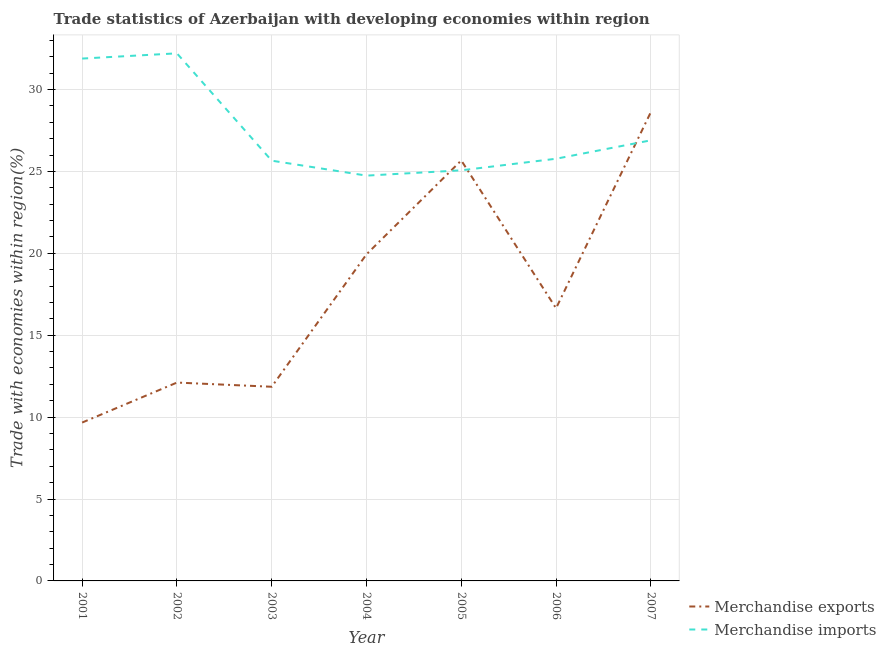Does the line corresponding to merchandise imports intersect with the line corresponding to merchandise exports?
Your answer should be compact. Yes. Is the number of lines equal to the number of legend labels?
Keep it short and to the point. Yes. What is the merchandise exports in 2004?
Keep it short and to the point. 19.94. Across all years, what is the maximum merchandise exports?
Offer a terse response. 28.62. Across all years, what is the minimum merchandise exports?
Offer a very short reply. 9.67. What is the total merchandise imports in the graph?
Provide a succinct answer. 192.24. What is the difference between the merchandise imports in 2001 and that in 2005?
Provide a succinct answer. 6.82. What is the difference between the merchandise exports in 2004 and the merchandise imports in 2005?
Ensure brevity in your answer.  -5.13. What is the average merchandise imports per year?
Offer a terse response. 27.46. In the year 2004, what is the difference between the merchandise exports and merchandise imports?
Provide a succinct answer. -4.8. What is the ratio of the merchandise exports in 2006 to that in 2007?
Ensure brevity in your answer.  0.58. Is the difference between the merchandise exports in 2001 and 2005 greater than the difference between the merchandise imports in 2001 and 2005?
Provide a short and direct response. No. What is the difference between the highest and the second highest merchandise imports?
Make the answer very short. 0.32. What is the difference between the highest and the lowest merchandise imports?
Offer a terse response. 7.47. In how many years, is the merchandise exports greater than the average merchandise exports taken over all years?
Your response must be concise. 3. Does the merchandise imports monotonically increase over the years?
Offer a terse response. No. Is the merchandise exports strictly less than the merchandise imports over the years?
Provide a short and direct response. No. How many lines are there?
Ensure brevity in your answer.  2. Does the graph contain grids?
Your response must be concise. Yes. Where does the legend appear in the graph?
Your answer should be compact. Bottom right. How many legend labels are there?
Your answer should be compact. 2. How are the legend labels stacked?
Your answer should be very brief. Vertical. What is the title of the graph?
Your answer should be compact. Trade statistics of Azerbaijan with developing economies within region. Does "Taxes on exports" appear as one of the legend labels in the graph?
Ensure brevity in your answer.  No. What is the label or title of the Y-axis?
Offer a terse response. Trade with economies within region(%). What is the Trade with economies within region(%) in Merchandise exports in 2001?
Give a very brief answer. 9.67. What is the Trade with economies within region(%) in Merchandise imports in 2001?
Offer a terse response. 31.89. What is the Trade with economies within region(%) of Merchandise exports in 2002?
Provide a succinct answer. 12.11. What is the Trade with economies within region(%) of Merchandise imports in 2002?
Your answer should be very brief. 32.21. What is the Trade with economies within region(%) in Merchandise exports in 2003?
Your answer should be compact. 11.85. What is the Trade with economies within region(%) of Merchandise imports in 2003?
Offer a very short reply. 25.66. What is the Trade with economies within region(%) in Merchandise exports in 2004?
Ensure brevity in your answer.  19.94. What is the Trade with economies within region(%) of Merchandise imports in 2004?
Provide a succinct answer. 24.74. What is the Trade with economies within region(%) in Merchandise exports in 2005?
Your answer should be compact. 25.67. What is the Trade with economies within region(%) of Merchandise imports in 2005?
Make the answer very short. 25.07. What is the Trade with economies within region(%) in Merchandise exports in 2006?
Offer a terse response. 16.65. What is the Trade with economies within region(%) of Merchandise imports in 2006?
Keep it short and to the point. 25.77. What is the Trade with economies within region(%) of Merchandise exports in 2007?
Your answer should be compact. 28.62. What is the Trade with economies within region(%) of Merchandise imports in 2007?
Make the answer very short. 26.9. Across all years, what is the maximum Trade with economies within region(%) in Merchandise exports?
Make the answer very short. 28.62. Across all years, what is the maximum Trade with economies within region(%) of Merchandise imports?
Your answer should be very brief. 32.21. Across all years, what is the minimum Trade with economies within region(%) of Merchandise exports?
Your response must be concise. 9.67. Across all years, what is the minimum Trade with economies within region(%) in Merchandise imports?
Give a very brief answer. 24.74. What is the total Trade with economies within region(%) of Merchandise exports in the graph?
Provide a succinct answer. 124.51. What is the total Trade with economies within region(%) of Merchandise imports in the graph?
Offer a very short reply. 192.24. What is the difference between the Trade with economies within region(%) of Merchandise exports in 2001 and that in 2002?
Your answer should be very brief. -2.44. What is the difference between the Trade with economies within region(%) of Merchandise imports in 2001 and that in 2002?
Your answer should be compact. -0.32. What is the difference between the Trade with economies within region(%) in Merchandise exports in 2001 and that in 2003?
Keep it short and to the point. -2.18. What is the difference between the Trade with economies within region(%) of Merchandise imports in 2001 and that in 2003?
Make the answer very short. 6.23. What is the difference between the Trade with economies within region(%) of Merchandise exports in 2001 and that in 2004?
Offer a terse response. -10.27. What is the difference between the Trade with economies within region(%) in Merchandise imports in 2001 and that in 2004?
Give a very brief answer. 7.15. What is the difference between the Trade with economies within region(%) of Merchandise exports in 2001 and that in 2005?
Give a very brief answer. -16. What is the difference between the Trade with economies within region(%) in Merchandise imports in 2001 and that in 2005?
Provide a short and direct response. 6.82. What is the difference between the Trade with economies within region(%) in Merchandise exports in 2001 and that in 2006?
Offer a terse response. -6.98. What is the difference between the Trade with economies within region(%) of Merchandise imports in 2001 and that in 2006?
Ensure brevity in your answer.  6.12. What is the difference between the Trade with economies within region(%) in Merchandise exports in 2001 and that in 2007?
Give a very brief answer. -18.95. What is the difference between the Trade with economies within region(%) of Merchandise imports in 2001 and that in 2007?
Your answer should be very brief. 4.99. What is the difference between the Trade with economies within region(%) in Merchandise exports in 2002 and that in 2003?
Provide a short and direct response. 0.26. What is the difference between the Trade with economies within region(%) in Merchandise imports in 2002 and that in 2003?
Provide a succinct answer. 6.55. What is the difference between the Trade with economies within region(%) of Merchandise exports in 2002 and that in 2004?
Provide a succinct answer. -7.83. What is the difference between the Trade with economies within region(%) of Merchandise imports in 2002 and that in 2004?
Your answer should be very brief. 7.47. What is the difference between the Trade with economies within region(%) in Merchandise exports in 2002 and that in 2005?
Provide a succinct answer. -13.56. What is the difference between the Trade with economies within region(%) in Merchandise imports in 2002 and that in 2005?
Keep it short and to the point. 7.14. What is the difference between the Trade with economies within region(%) of Merchandise exports in 2002 and that in 2006?
Keep it short and to the point. -4.54. What is the difference between the Trade with economies within region(%) in Merchandise imports in 2002 and that in 2006?
Your answer should be very brief. 6.43. What is the difference between the Trade with economies within region(%) in Merchandise exports in 2002 and that in 2007?
Ensure brevity in your answer.  -16.51. What is the difference between the Trade with economies within region(%) in Merchandise imports in 2002 and that in 2007?
Give a very brief answer. 5.31. What is the difference between the Trade with economies within region(%) in Merchandise exports in 2003 and that in 2004?
Provide a short and direct response. -8.09. What is the difference between the Trade with economies within region(%) of Merchandise imports in 2003 and that in 2004?
Ensure brevity in your answer.  0.91. What is the difference between the Trade with economies within region(%) in Merchandise exports in 2003 and that in 2005?
Your answer should be very brief. -13.82. What is the difference between the Trade with economies within region(%) in Merchandise imports in 2003 and that in 2005?
Your answer should be very brief. 0.59. What is the difference between the Trade with economies within region(%) in Merchandise exports in 2003 and that in 2006?
Offer a terse response. -4.79. What is the difference between the Trade with economies within region(%) in Merchandise imports in 2003 and that in 2006?
Your answer should be compact. -0.12. What is the difference between the Trade with economies within region(%) in Merchandise exports in 2003 and that in 2007?
Provide a succinct answer. -16.77. What is the difference between the Trade with economies within region(%) in Merchandise imports in 2003 and that in 2007?
Your answer should be very brief. -1.24. What is the difference between the Trade with economies within region(%) in Merchandise exports in 2004 and that in 2005?
Make the answer very short. -5.73. What is the difference between the Trade with economies within region(%) in Merchandise imports in 2004 and that in 2005?
Your answer should be very brief. -0.32. What is the difference between the Trade with economies within region(%) in Merchandise exports in 2004 and that in 2006?
Give a very brief answer. 3.29. What is the difference between the Trade with economies within region(%) of Merchandise imports in 2004 and that in 2006?
Provide a short and direct response. -1.03. What is the difference between the Trade with economies within region(%) in Merchandise exports in 2004 and that in 2007?
Ensure brevity in your answer.  -8.68. What is the difference between the Trade with economies within region(%) in Merchandise imports in 2004 and that in 2007?
Provide a succinct answer. -2.16. What is the difference between the Trade with economies within region(%) of Merchandise exports in 2005 and that in 2006?
Your response must be concise. 9.02. What is the difference between the Trade with economies within region(%) in Merchandise imports in 2005 and that in 2006?
Your response must be concise. -0.71. What is the difference between the Trade with economies within region(%) of Merchandise exports in 2005 and that in 2007?
Your response must be concise. -2.95. What is the difference between the Trade with economies within region(%) in Merchandise imports in 2005 and that in 2007?
Ensure brevity in your answer.  -1.83. What is the difference between the Trade with economies within region(%) of Merchandise exports in 2006 and that in 2007?
Make the answer very short. -11.98. What is the difference between the Trade with economies within region(%) of Merchandise imports in 2006 and that in 2007?
Your answer should be compact. -1.12. What is the difference between the Trade with economies within region(%) of Merchandise exports in 2001 and the Trade with economies within region(%) of Merchandise imports in 2002?
Your answer should be very brief. -22.54. What is the difference between the Trade with economies within region(%) of Merchandise exports in 2001 and the Trade with economies within region(%) of Merchandise imports in 2003?
Your answer should be compact. -15.99. What is the difference between the Trade with economies within region(%) in Merchandise exports in 2001 and the Trade with economies within region(%) in Merchandise imports in 2004?
Your answer should be very brief. -15.07. What is the difference between the Trade with economies within region(%) in Merchandise exports in 2001 and the Trade with economies within region(%) in Merchandise imports in 2005?
Give a very brief answer. -15.4. What is the difference between the Trade with economies within region(%) of Merchandise exports in 2001 and the Trade with economies within region(%) of Merchandise imports in 2006?
Offer a terse response. -16.11. What is the difference between the Trade with economies within region(%) in Merchandise exports in 2001 and the Trade with economies within region(%) in Merchandise imports in 2007?
Provide a succinct answer. -17.23. What is the difference between the Trade with economies within region(%) of Merchandise exports in 2002 and the Trade with economies within region(%) of Merchandise imports in 2003?
Your answer should be compact. -13.55. What is the difference between the Trade with economies within region(%) of Merchandise exports in 2002 and the Trade with economies within region(%) of Merchandise imports in 2004?
Provide a succinct answer. -12.63. What is the difference between the Trade with economies within region(%) of Merchandise exports in 2002 and the Trade with economies within region(%) of Merchandise imports in 2005?
Keep it short and to the point. -12.96. What is the difference between the Trade with economies within region(%) of Merchandise exports in 2002 and the Trade with economies within region(%) of Merchandise imports in 2006?
Your response must be concise. -13.66. What is the difference between the Trade with economies within region(%) of Merchandise exports in 2002 and the Trade with economies within region(%) of Merchandise imports in 2007?
Offer a terse response. -14.79. What is the difference between the Trade with economies within region(%) in Merchandise exports in 2003 and the Trade with economies within region(%) in Merchandise imports in 2004?
Provide a short and direct response. -12.89. What is the difference between the Trade with economies within region(%) of Merchandise exports in 2003 and the Trade with economies within region(%) of Merchandise imports in 2005?
Give a very brief answer. -13.21. What is the difference between the Trade with economies within region(%) in Merchandise exports in 2003 and the Trade with economies within region(%) in Merchandise imports in 2006?
Your response must be concise. -13.92. What is the difference between the Trade with economies within region(%) of Merchandise exports in 2003 and the Trade with economies within region(%) of Merchandise imports in 2007?
Ensure brevity in your answer.  -15.04. What is the difference between the Trade with economies within region(%) of Merchandise exports in 2004 and the Trade with economies within region(%) of Merchandise imports in 2005?
Provide a succinct answer. -5.13. What is the difference between the Trade with economies within region(%) in Merchandise exports in 2004 and the Trade with economies within region(%) in Merchandise imports in 2006?
Make the answer very short. -5.83. What is the difference between the Trade with economies within region(%) of Merchandise exports in 2004 and the Trade with economies within region(%) of Merchandise imports in 2007?
Offer a very short reply. -6.96. What is the difference between the Trade with economies within region(%) of Merchandise exports in 2005 and the Trade with economies within region(%) of Merchandise imports in 2006?
Offer a very short reply. -0.1. What is the difference between the Trade with economies within region(%) of Merchandise exports in 2005 and the Trade with economies within region(%) of Merchandise imports in 2007?
Your answer should be very brief. -1.23. What is the difference between the Trade with economies within region(%) of Merchandise exports in 2006 and the Trade with economies within region(%) of Merchandise imports in 2007?
Offer a very short reply. -10.25. What is the average Trade with economies within region(%) in Merchandise exports per year?
Provide a succinct answer. 17.79. What is the average Trade with economies within region(%) of Merchandise imports per year?
Offer a very short reply. 27.46. In the year 2001, what is the difference between the Trade with economies within region(%) in Merchandise exports and Trade with economies within region(%) in Merchandise imports?
Offer a terse response. -22.22. In the year 2002, what is the difference between the Trade with economies within region(%) in Merchandise exports and Trade with economies within region(%) in Merchandise imports?
Make the answer very short. -20.1. In the year 2003, what is the difference between the Trade with economies within region(%) in Merchandise exports and Trade with economies within region(%) in Merchandise imports?
Offer a very short reply. -13.8. In the year 2004, what is the difference between the Trade with economies within region(%) in Merchandise exports and Trade with economies within region(%) in Merchandise imports?
Make the answer very short. -4.8. In the year 2005, what is the difference between the Trade with economies within region(%) of Merchandise exports and Trade with economies within region(%) of Merchandise imports?
Your answer should be very brief. 0.6. In the year 2006, what is the difference between the Trade with economies within region(%) of Merchandise exports and Trade with economies within region(%) of Merchandise imports?
Give a very brief answer. -9.13. In the year 2007, what is the difference between the Trade with economies within region(%) in Merchandise exports and Trade with economies within region(%) in Merchandise imports?
Ensure brevity in your answer.  1.72. What is the ratio of the Trade with economies within region(%) in Merchandise exports in 2001 to that in 2002?
Make the answer very short. 0.8. What is the ratio of the Trade with economies within region(%) in Merchandise imports in 2001 to that in 2002?
Give a very brief answer. 0.99. What is the ratio of the Trade with economies within region(%) of Merchandise exports in 2001 to that in 2003?
Provide a short and direct response. 0.82. What is the ratio of the Trade with economies within region(%) of Merchandise imports in 2001 to that in 2003?
Give a very brief answer. 1.24. What is the ratio of the Trade with economies within region(%) of Merchandise exports in 2001 to that in 2004?
Your response must be concise. 0.48. What is the ratio of the Trade with economies within region(%) in Merchandise imports in 2001 to that in 2004?
Offer a very short reply. 1.29. What is the ratio of the Trade with economies within region(%) of Merchandise exports in 2001 to that in 2005?
Your answer should be very brief. 0.38. What is the ratio of the Trade with economies within region(%) in Merchandise imports in 2001 to that in 2005?
Your response must be concise. 1.27. What is the ratio of the Trade with economies within region(%) in Merchandise exports in 2001 to that in 2006?
Provide a short and direct response. 0.58. What is the ratio of the Trade with economies within region(%) in Merchandise imports in 2001 to that in 2006?
Give a very brief answer. 1.24. What is the ratio of the Trade with economies within region(%) in Merchandise exports in 2001 to that in 2007?
Offer a terse response. 0.34. What is the ratio of the Trade with economies within region(%) in Merchandise imports in 2001 to that in 2007?
Ensure brevity in your answer.  1.19. What is the ratio of the Trade with economies within region(%) in Merchandise exports in 2002 to that in 2003?
Provide a succinct answer. 1.02. What is the ratio of the Trade with economies within region(%) of Merchandise imports in 2002 to that in 2003?
Keep it short and to the point. 1.26. What is the ratio of the Trade with economies within region(%) of Merchandise exports in 2002 to that in 2004?
Provide a succinct answer. 0.61. What is the ratio of the Trade with economies within region(%) in Merchandise imports in 2002 to that in 2004?
Your answer should be very brief. 1.3. What is the ratio of the Trade with economies within region(%) of Merchandise exports in 2002 to that in 2005?
Offer a very short reply. 0.47. What is the ratio of the Trade with economies within region(%) of Merchandise imports in 2002 to that in 2005?
Provide a succinct answer. 1.28. What is the ratio of the Trade with economies within region(%) of Merchandise exports in 2002 to that in 2006?
Offer a terse response. 0.73. What is the ratio of the Trade with economies within region(%) in Merchandise imports in 2002 to that in 2006?
Ensure brevity in your answer.  1.25. What is the ratio of the Trade with economies within region(%) of Merchandise exports in 2002 to that in 2007?
Ensure brevity in your answer.  0.42. What is the ratio of the Trade with economies within region(%) in Merchandise imports in 2002 to that in 2007?
Your response must be concise. 1.2. What is the ratio of the Trade with economies within region(%) in Merchandise exports in 2003 to that in 2004?
Your answer should be very brief. 0.59. What is the ratio of the Trade with economies within region(%) in Merchandise imports in 2003 to that in 2004?
Offer a very short reply. 1.04. What is the ratio of the Trade with economies within region(%) of Merchandise exports in 2003 to that in 2005?
Your answer should be very brief. 0.46. What is the ratio of the Trade with economies within region(%) of Merchandise imports in 2003 to that in 2005?
Provide a short and direct response. 1.02. What is the ratio of the Trade with economies within region(%) of Merchandise exports in 2003 to that in 2006?
Your answer should be very brief. 0.71. What is the ratio of the Trade with economies within region(%) in Merchandise imports in 2003 to that in 2006?
Offer a very short reply. 1. What is the ratio of the Trade with economies within region(%) of Merchandise exports in 2003 to that in 2007?
Provide a succinct answer. 0.41. What is the ratio of the Trade with economies within region(%) in Merchandise imports in 2003 to that in 2007?
Offer a terse response. 0.95. What is the ratio of the Trade with economies within region(%) in Merchandise exports in 2004 to that in 2005?
Offer a very short reply. 0.78. What is the ratio of the Trade with economies within region(%) of Merchandise imports in 2004 to that in 2005?
Your response must be concise. 0.99. What is the ratio of the Trade with economies within region(%) in Merchandise exports in 2004 to that in 2006?
Keep it short and to the point. 1.2. What is the ratio of the Trade with economies within region(%) in Merchandise exports in 2004 to that in 2007?
Keep it short and to the point. 0.7. What is the ratio of the Trade with economies within region(%) of Merchandise imports in 2004 to that in 2007?
Your answer should be compact. 0.92. What is the ratio of the Trade with economies within region(%) in Merchandise exports in 2005 to that in 2006?
Your answer should be compact. 1.54. What is the ratio of the Trade with economies within region(%) of Merchandise imports in 2005 to that in 2006?
Your answer should be very brief. 0.97. What is the ratio of the Trade with economies within region(%) in Merchandise exports in 2005 to that in 2007?
Keep it short and to the point. 0.9. What is the ratio of the Trade with economies within region(%) in Merchandise imports in 2005 to that in 2007?
Your answer should be compact. 0.93. What is the ratio of the Trade with economies within region(%) of Merchandise exports in 2006 to that in 2007?
Your response must be concise. 0.58. What is the ratio of the Trade with economies within region(%) in Merchandise imports in 2006 to that in 2007?
Offer a terse response. 0.96. What is the difference between the highest and the second highest Trade with economies within region(%) of Merchandise exports?
Your answer should be compact. 2.95. What is the difference between the highest and the second highest Trade with economies within region(%) of Merchandise imports?
Your response must be concise. 0.32. What is the difference between the highest and the lowest Trade with economies within region(%) of Merchandise exports?
Your response must be concise. 18.95. What is the difference between the highest and the lowest Trade with economies within region(%) in Merchandise imports?
Give a very brief answer. 7.47. 